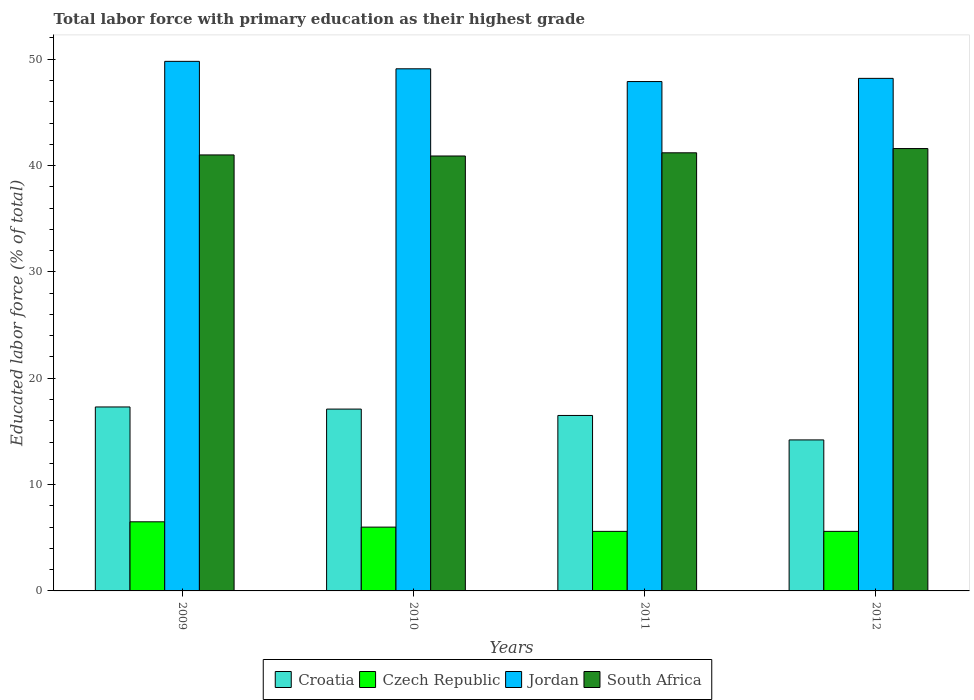Are the number of bars per tick equal to the number of legend labels?
Your answer should be very brief. Yes. How many bars are there on the 4th tick from the left?
Provide a short and direct response. 4. How many bars are there on the 2nd tick from the right?
Offer a very short reply. 4. What is the label of the 4th group of bars from the left?
Your answer should be compact. 2012. What is the percentage of total labor force with primary education in Croatia in 2010?
Offer a very short reply. 17.1. Across all years, what is the maximum percentage of total labor force with primary education in South Africa?
Your answer should be very brief. 41.6. Across all years, what is the minimum percentage of total labor force with primary education in Jordan?
Offer a terse response. 47.9. What is the total percentage of total labor force with primary education in Croatia in the graph?
Make the answer very short. 65.1. What is the difference between the percentage of total labor force with primary education in South Africa in 2009 and that in 2010?
Offer a terse response. 0.1. What is the difference between the percentage of total labor force with primary education in South Africa in 2009 and the percentage of total labor force with primary education in Jordan in 2012?
Ensure brevity in your answer.  -7.2. What is the average percentage of total labor force with primary education in Jordan per year?
Make the answer very short. 48.75. In the year 2012, what is the difference between the percentage of total labor force with primary education in Croatia and percentage of total labor force with primary education in South Africa?
Your response must be concise. -27.4. What is the ratio of the percentage of total labor force with primary education in South Africa in 2010 to that in 2012?
Your answer should be very brief. 0.98. What is the difference between the highest and the second highest percentage of total labor force with primary education in Croatia?
Your answer should be very brief. 0.2. What is the difference between the highest and the lowest percentage of total labor force with primary education in Jordan?
Give a very brief answer. 1.9. Is it the case that in every year, the sum of the percentage of total labor force with primary education in Jordan and percentage of total labor force with primary education in Czech Republic is greater than the sum of percentage of total labor force with primary education in South Africa and percentage of total labor force with primary education in Croatia?
Provide a succinct answer. No. What does the 4th bar from the left in 2012 represents?
Give a very brief answer. South Africa. What does the 2nd bar from the right in 2009 represents?
Your answer should be compact. Jordan. How many bars are there?
Ensure brevity in your answer.  16. What is the difference between two consecutive major ticks on the Y-axis?
Offer a very short reply. 10. Are the values on the major ticks of Y-axis written in scientific E-notation?
Provide a short and direct response. No. Does the graph contain grids?
Your answer should be very brief. No. Where does the legend appear in the graph?
Make the answer very short. Bottom center. How many legend labels are there?
Offer a terse response. 4. How are the legend labels stacked?
Provide a short and direct response. Horizontal. What is the title of the graph?
Keep it short and to the point. Total labor force with primary education as their highest grade. What is the label or title of the X-axis?
Your answer should be very brief. Years. What is the label or title of the Y-axis?
Provide a succinct answer. Educated labor force (% of total). What is the Educated labor force (% of total) in Croatia in 2009?
Offer a terse response. 17.3. What is the Educated labor force (% of total) in Czech Republic in 2009?
Your answer should be very brief. 6.5. What is the Educated labor force (% of total) of Jordan in 2009?
Offer a terse response. 49.8. What is the Educated labor force (% of total) in South Africa in 2009?
Provide a succinct answer. 41. What is the Educated labor force (% of total) of Croatia in 2010?
Your response must be concise. 17.1. What is the Educated labor force (% of total) in Czech Republic in 2010?
Provide a succinct answer. 6. What is the Educated labor force (% of total) of Jordan in 2010?
Offer a very short reply. 49.1. What is the Educated labor force (% of total) in South Africa in 2010?
Give a very brief answer. 40.9. What is the Educated labor force (% of total) in Czech Republic in 2011?
Ensure brevity in your answer.  5.6. What is the Educated labor force (% of total) in Jordan in 2011?
Your answer should be compact. 47.9. What is the Educated labor force (% of total) in South Africa in 2011?
Give a very brief answer. 41.2. What is the Educated labor force (% of total) of Croatia in 2012?
Offer a terse response. 14.2. What is the Educated labor force (% of total) in Czech Republic in 2012?
Give a very brief answer. 5.6. What is the Educated labor force (% of total) of Jordan in 2012?
Give a very brief answer. 48.2. What is the Educated labor force (% of total) in South Africa in 2012?
Give a very brief answer. 41.6. Across all years, what is the maximum Educated labor force (% of total) in Croatia?
Give a very brief answer. 17.3. Across all years, what is the maximum Educated labor force (% of total) in Jordan?
Give a very brief answer. 49.8. Across all years, what is the maximum Educated labor force (% of total) in South Africa?
Provide a succinct answer. 41.6. Across all years, what is the minimum Educated labor force (% of total) of Croatia?
Provide a succinct answer. 14.2. Across all years, what is the minimum Educated labor force (% of total) in Czech Republic?
Your response must be concise. 5.6. Across all years, what is the minimum Educated labor force (% of total) of Jordan?
Offer a terse response. 47.9. Across all years, what is the minimum Educated labor force (% of total) in South Africa?
Provide a short and direct response. 40.9. What is the total Educated labor force (% of total) of Croatia in the graph?
Keep it short and to the point. 65.1. What is the total Educated labor force (% of total) of Czech Republic in the graph?
Provide a short and direct response. 23.7. What is the total Educated labor force (% of total) in Jordan in the graph?
Offer a terse response. 195. What is the total Educated labor force (% of total) of South Africa in the graph?
Offer a very short reply. 164.7. What is the difference between the Educated labor force (% of total) of Czech Republic in 2009 and that in 2010?
Your response must be concise. 0.5. What is the difference between the Educated labor force (% of total) in South Africa in 2009 and that in 2010?
Offer a terse response. 0.1. What is the difference between the Educated labor force (% of total) of Czech Republic in 2009 and that in 2011?
Your response must be concise. 0.9. What is the difference between the Educated labor force (% of total) in Jordan in 2009 and that in 2011?
Offer a terse response. 1.9. What is the difference between the Educated labor force (% of total) in South Africa in 2009 and that in 2011?
Your answer should be very brief. -0.2. What is the difference between the Educated labor force (% of total) in Czech Republic in 2009 and that in 2012?
Keep it short and to the point. 0.9. What is the difference between the Educated labor force (% of total) of South Africa in 2009 and that in 2012?
Make the answer very short. -0.6. What is the difference between the Educated labor force (% of total) in Croatia in 2010 and that in 2011?
Give a very brief answer. 0.6. What is the difference between the Educated labor force (% of total) in South Africa in 2010 and that in 2011?
Your response must be concise. -0.3. What is the difference between the Educated labor force (% of total) of Croatia in 2010 and that in 2012?
Your response must be concise. 2.9. What is the difference between the Educated labor force (% of total) in Jordan in 2010 and that in 2012?
Offer a very short reply. 0.9. What is the difference between the Educated labor force (% of total) in South Africa in 2010 and that in 2012?
Provide a succinct answer. -0.7. What is the difference between the Educated labor force (% of total) in Croatia in 2011 and that in 2012?
Provide a succinct answer. 2.3. What is the difference between the Educated labor force (% of total) of Czech Republic in 2011 and that in 2012?
Give a very brief answer. 0. What is the difference between the Educated labor force (% of total) in South Africa in 2011 and that in 2012?
Ensure brevity in your answer.  -0.4. What is the difference between the Educated labor force (% of total) of Croatia in 2009 and the Educated labor force (% of total) of Jordan in 2010?
Make the answer very short. -31.8. What is the difference between the Educated labor force (% of total) in Croatia in 2009 and the Educated labor force (% of total) in South Africa in 2010?
Your response must be concise. -23.6. What is the difference between the Educated labor force (% of total) of Czech Republic in 2009 and the Educated labor force (% of total) of Jordan in 2010?
Offer a terse response. -42.6. What is the difference between the Educated labor force (% of total) in Czech Republic in 2009 and the Educated labor force (% of total) in South Africa in 2010?
Provide a succinct answer. -34.4. What is the difference between the Educated labor force (% of total) in Jordan in 2009 and the Educated labor force (% of total) in South Africa in 2010?
Keep it short and to the point. 8.9. What is the difference between the Educated labor force (% of total) of Croatia in 2009 and the Educated labor force (% of total) of Jordan in 2011?
Provide a short and direct response. -30.6. What is the difference between the Educated labor force (% of total) in Croatia in 2009 and the Educated labor force (% of total) in South Africa in 2011?
Offer a very short reply. -23.9. What is the difference between the Educated labor force (% of total) in Czech Republic in 2009 and the Educated labor force (% of total) in Jordan in 2011?
Offer a terse response. -41.4. What is the difference between the Educated labor force (% of total) in Czech Republic in 2009 and the Educated labor force (% of total) in South Africa in 2011?
Offer a terse response. -34.7. What is the difference between the Educated labor force (% of total) in Jordan in 2009 and the Educated labor force (% of total) in South Africa in 2011?
Make the answer very short. 8.6. What is the difference between the Educated labor force (% of total) of Croatia in 2009 and the Educated labor force (% of total) of Czech Republic in 2012?
Provide a short and direct response. 11.7. What is the difference between the Educated labor force (% of total) in Croatia in 2009 and the Educated labor force (% of total) in Jordan in 2012?
Offer a terse response. -30.9. What is the difference between the Educated labor force (% of total) of Croatia in 2009 and the Educated labor force (% of total) of South Africa in 2012?
Your answer should be compact. -24.3. What is the difference between the Educated labor force (% of total) of Czech Republic in 2009 and the Educated labor force (% of total) of Jordan in 2012?
Provide a succinct answer. -41.7. What is the difference between the Educated labor force (% of total) in Czech Republic in 2009 and the Educated labor force (% of total) in South Africa in 2012?
Your answer should be very brief. -35.1. What is the difference between the Educated labor force (% of total) of Jordan in 2009 and the Educated labor force (% of total) of South Africa in 2012?
Your answer should be compact. 8.2. What is the difference between the Educated labor force (% of total) in Croatia in 2010 and the Educated labor force (% of total) in Jordan in 2011?
Give a very brief answer. -30.8. What is the difference between the Educated labor force (% of total) of Croatia in 2010 and the Educated labor force (% of total) of South Africa in 2011?
Make the answer very short. -24.1. What is the difference between the Educated labor force (% of total) of Czech Republic in 2010 and the Educated labor force (% of total) of Jordan in 2011?
Ensure brevity in your answer.  -41.9. What is the difference between the Educated labor force (% of total) in Czech Republic in 2010 and the Educated labor force (% of total) in South Africa in 2011?
Provide a short and direct response. -35.2. What is the difference between the Educated labor force (% of total) in Jordan in 2010 and the Educated labor force (% of total) in South Africa in 2011?
Your response must be concise. 7.9. What is the difference between the Educated labor force (% of total) in Croatia in 2010 and the Educated labor force (% of total) in Jordan in 2012?
Provide a succinct answer. -31.1. What is the difference between the Educated labor force (% of total) in Croatia in 2010 and the Educated labor force (% of total) in South Africa in 2012?
Your response must be concise. -24.5. What is the difference between the Educated labor force (% of total) of Czech Republic in 2010 and the Educated labor force (% of total) of Jordan in 2012?
Ensure brevity in your answer.  -42.2. What is the difference between the Educated labor force (% of total) of Czech Republic in 2010 and the Educated labor force (% of total) of South Africa in 2012?
Offer a very short reply. -35.6. What is the difference between the Educated labor force (% of total) of Jordan in 2010 and the Educated labor force (% of total) of South Africa in 2012?
Your response must be concise. 7.5. What is the difference between the Educated labor force (% of total) in Croatia in 2011 and the Educated labor force (% of total) in Czech Republic in 2012?
Provide a succinct answer. 10.9. What is the difference between the Educated labor force (% of total) of Croatia in 2011 and the Educated labor force (% of total) of Jordan in 2012?
Offer a terse response. -31.7. What is the difference between the Educated labor force (% of total) in Croatia in 2011 and the Educated labor force (% of total) in South Africa in 2012?
Offer a terse response. -25.1. What is the difference between the Educated labor force (% of total) of Czech Republic in 2011 and the Educated labor force (% of total) of Jordan in 2012?
Offer a terse response. -42.6. What is the difference between the Educated labor force (% of total) in Czech Republic in 2011 and the Educated labor force (% of total) in South Africa in 2012?
Your answer should be compact. -36. What is the difference between the Educated labor force (% of total) in Jordan in 2011 and the Educated labor force (% of total) in South Africa in 2012?
Ensure brevity in your answer.  6.3. What is the average Educated labor force (% of total) in Croatia per year?
Your answer should be compact. 16.27. What is the average Educated labor force (% of total) in Czech Republic per year?
Give a very brief answer. 5.92. What is the average Educated labor force (% of total) of Jordan per year?
Your response must be concise. 48.75. What is the average Educated labor force (% of total) of South Africa per year?
Offer a terse response. 41.17. In the year 2009, what is the difference between the Educated labor force (% of total) in Croatia and Educated labor force (% of total) in Czech Republic?
Keep it short and to the point. 10.8. In the year 2009, what is the difference between the Educated labor force (% of total) in Croatia and Educated labor force (% of total) in Jordan?
Make the answer very short. -32.5. In the year 2009, what is the difference between the Educated labor force (% of total) in Croatia and Educated labor force (% of total) in South Africa?
Provide a short and direct response. -23.7. In the year 2009, what is the difference between the Educated labor force (% of total) in Czech Republic and Educated labor force (% of total) in Jordan?
Keep it short and to the point. -43.3. In the year 2009, what is the difference between the Educated labor force (% of total) of Czech Republic and Educated labor force (% of total) of South Africa?
Ensure brevity in your answer.  -34.5. In the year 2010, what is the difference between the Educated labor force (% of total) in Croatia and Educated labor force (% of total) in Jordan?
Give a very brief answer. -32. In the year 2010, what is the difference between the Educated labor force (% of total) in Croatia and Educated labor force (% of total) in South Africa?
Offer a very short reply. -23.8. In the year 2010, what is the difference between the Educated labor force (% of total) of Czech Republic and Educated labor force (% of total) of Jordan?
Ensure brevity in your answer.  -43.1. In the year 2010, what is the difference between the Educated labor force (% of total) in Czech Republic and Educated labor force (% of total) in South Africa?
Your answer should be compact. -34.9. In the year 2010, what is the difference between the Educated labor force (% of total) in Jordan and Educated labor force (% of total) in South Africa?
Offer a very short reply. 8.2. In the year 2011, what is the difference between the Educated labor force (% of total) of Croatia and Educated labor force (% of total) of Czech Republic?
Ensure brevity in your answer.  10.9. In the year 2011, what is the difference between the Educated labor force (% of total) of Croatia and Educated labor force (% of total) of Jordan?
Provide a short and direct response. -31.4. In the year 2011, what is the difference between the Educated labor force (% of total) in Croatia and Educated labor force (% of total) in South Africa?
Your answer should be compact. -24.7. In the year 2011, what is the difference between the Educated labor force (% of total) of Czech Republic and Educated labor force (% of total) of Jordan?
Keep it short and to the point. -42.3. In the year 2011, what is the difference between the Educated labor force (% of total) of Czech Republic and Educated labor force (% of total) of South Africa?
Ensure brevity in your answer.  -35.6. In the year 2011, what is the difference between the Educated labor force (% of total) in Jordan and Educated labor force (% of total) in South Africa?
Provide a short and direct response. 6.7. In the year 2012, what is the difference between the Educated labor force (% of total) in Croatia and Educated labor force (% of total) in Czech Republic?
Your answer should be very brief. 8.6. In the year 2012, what is the difference between the Educated labor force (% of total) of Croatia and Educated labor force (% of total) of Jordan?
Ensure brevity in your answer.  -34. In the year 2012, what is the difference between the Educated labor force (% of total) in Croatia and Educated labor force (% of total) in South Africa?
Provide a short and direct response. -27.4. In the year 2012, what is the difference between the Educated labor force (% of total) in Czech Republic and Educated labor force (% of total) in Jordan?
Keep it short and to the point. -42.6. In the year 2012, what is the difference between the Educated labor force (% of total) in Czech Republic and Educated labor force (% of total) in South Africa?
Provide a succinct answer. -36. In the year 2012, what is the difference between the Educated labor force (% of total) in Jordan and Educated labor force (% of total) in South Africa?
Provide a short and direct response. 6.6. What is the ratio of the Educated labor force (% of total) in Croatia in 2009 to that in 2010?
Your answer should be compact. 1.01. What is the ratio of the Educated labor force (% of total) in Czech Republic in 2009 to that in 2010?
Ensure brevity in your answer.  1.08. What is the ratio of the Educated labor force (% of total) in Jordan in 2009 to that in 2010?
Provide a succinct answer. 1.01. What is the ratio of the Educated labor force (% of total) in Croatia in 2009 to that in 2011?
Give a very brief answer. 1.05. What is the ratio of the Educated labor force (% of total) in Czech Republic in 2009 to that in 2011?
Ensure brevity in your answer.  1.16. What is the ratio of the Educated labor force (% of total) of Jordan in 2009 to that in 2011?
Give a very brief answer. 1.04. What is the ratio of the Educated labor force (% of total) of Croatia in 2009 to that in 2012?
Offer a terse response. 1.22. What is the ratio of the Educated labor force (% of total) of Czech Republic in 2009 to that in 2012?
Your answer should be compact. 1.16. What is the ratio of the Educated labor force (% of total) in Jordan in 2009 to that in 2012?
Your response must be concise. 1.03. What is the ratio of the Educated labor force (% of total) in South Africa in 2009 to that in 2012?
Provide a succinct answer. 0.99. What is the ratio of the Educated labor force (% of total) of Croatia in 2010 to that in 2011?
Give a very brief answer. 1.04. What is the ratio of the Educated labor force (% of total) in Czech Republic in 2010 to that in 2011?
Make the answer very short. 1.07. What is the ratio of the Educated labor force (% of total) in Jordan in 2010 to that in 2011?
Provide a succinct answer. 1.03. What is the ratio of the Educated labor force (% of total) in South Africa in 2010 to that in 2011?
Provide a short and direct response. 0.99. What is the ratio of the Educated labor force (% of total) in Croatia in 2010 to that in 2012?
Your answer should be very brief. 1.2. What is the ratio of the Educated labor force (% of total) of Czech Republic in 2010 to that in 2012?
Provide a succinct answer. 1.07. What is the ratio of the Educated labor force (% of total) of Jordan in 2010 to that in 2012?
Offer a terse response. 1.02. What is the ratio of the Educated labor force (% of total) of South Africa in 2010 to that in 2012?
Give a very brief answer. 0.98. What is the ratio of the Educated labor force (% of total) in Croatia in 2011 to that in 2012?
Your answer should be very brief. 1.16. What is the difference between the highest and the second highest Educated labor force (% of total) in Croatia?
Give a very brief answer. 0.2. What is the difference between the highest and the second highest Educated labor force (% of total) of Czech Republic?
Give a very brief answer. 0.5. What is the difference between the highest and the second highest Educated labor force (% of total) in Jordan?
Your answer should be very brief. 0.7. What is the difference between the highest and the lowest Educated labor force (% of total) in Czech Republic?
Provide a short and direct response. 0.9. 